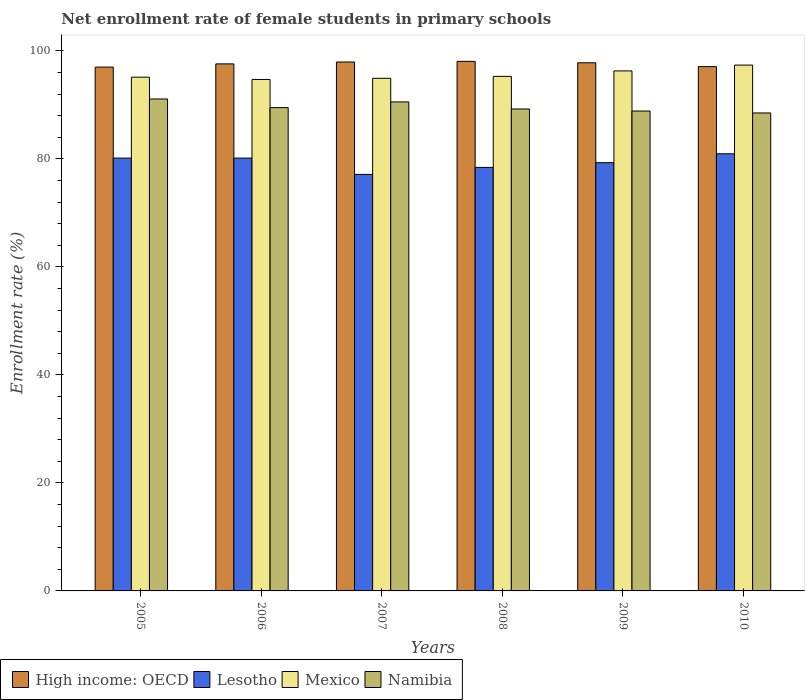How many different coloured bars are there?
Give a very brief answer. 4. How many groups of bars are there?
Your response must be concise. 6. Are the number of bars per tick equal to the number of legend labels?
Your response must be concise. Yes. Are the number of bars on each tick of the X-axis equal?
Provide a succinct answer. Yes. In how many cases, is the number of bars for a given year not equal to the number of legend labels?
Your answer should be compact. 0. What is the net enrollment rate of female students in primary schools in Lesotho in 2006?
Offer a terse response. 80.16. Across all years, what is the maximum net enrollment rate of female students in primary schools in Mexico?
Provide a succinct answer. 97.39. Across all years, what is the minimum net enrollment rate of female students in primary schools in Namibia?
Keep it short and to the point. 88.52. What is the total net enrollment rate of female students in primary schools in Namibia in the graph?
Provide a short and direct response. 537.83. What is the difference between the net enrollment rate of female students in primary schools in High income: OECD in 2006 and that in 2007?
Keep it short and to the point. -0.35. What is the difference between the net enrollment rate of female students in primary schools in Lesotho in 2008 and the net enrollment rate of female students in primary schools in Mexico in 2005?
Keep it short and to the point. -16.71. What is the average net enrollment rate of female students in primary schools in High income: OECD per year?
Provide a short and direct response. 97.59. In the year 2010, what is the difference between the net enrollment rate of female students in primary schools in Namibia and net enrollment rate of female students in primary schools in High income: OECD?
Make the answer very short. -8.58. What is the ratio of the net enrollment rate of female students in primary schools in Mexico in 2007 to that in 2009?
Provide a short and direct response. 0.99. What is the difference between the highest and the second highest net enrollment rate of female students in primary schools in Namibia?
Your answer should be compact. 0.54. What is the difference between the highest and the lowest net enrollment rate of female students in primary schools in Mexico?
Offer a terse response. 2.66. Is it the case that in every year, the sum of the net enrollment rate of female students in primary schools in High income: OECD and net enrollment rate of female students in primary schools in Namibia is greater than the sum of net enrollment rate of female students in primary schools in Lesotho and net enrollment rate of female students in primary schools in Mexico?
Keep it short and to the point. No. What does the 2nd bar from the left in 2007 represents?
Ensure brevity in your answer.  Lesotho. What does the 1st bar from the right in 2005 represents?
Keep it short and to the point. Namibia. Is it the case that in every year, the sum of the net enrollment rate of female students in primary schools in Mexico and net enrollment rate of female students in primary schools in Namibia is greater than the net enrollment rate of female students in primary schools in High income: OECD?
Keep it short and to the point. Yes. How many bars are there?
Provide a short and direct response. 24. Are all the bars in the graph horizontal?
Offer a very short reply. No. How many years are there in the graph?
Provide a succinct answer. 6. What is the difference between two consecutive major ticks on the Y-axis?
Keep it short and to the point. 20. Does the graph contain grids?
Ensure brevity in your answer.  No. Where does the legend appear in the graph?
Provide a short and direct response. Bottom left. What is the title of the graph?
Keep it short and to the point. Net enrollment rate of female students in primary schools. Does "Saudi Arabia" appear as one of the legend labels in the graph?
Give a very brief answer. No. What is the label or title of the Y-axis?
Give a very brief answer. Enrollment rate (%). What is the Enrollment rate (%) of High income: OECD in 2005?
Keep it short and to the point. 97.01. What is the Enrollment rate (%) in Lesotho in 2005?
Provide a short and direct response. 80.16. What is the Enrollment rate (%) in Mexico in 2005?
Ensure brevity in your answer.  95.14. What is the Enrollment rate (%) of Namibia in 2005?
Your response must be concise. 91.11. What is the Enrollment rate (%) in High income: OECD in 2006?
Keep it short and to the point. 97.61. What is the Enrollment rate (%) in Lesotho in 2006?
Make the answer very short. 80.16. What is the Enrollment rate (%) of Mexico in 2006?
Ensure brevity in your answer.  94.72. What is the Enrollment rate (%) in Namibia in 2006?
Keep it short and to the point. 89.51. What is the Enrollment rate (%) in High income: OECD in 2007?
Your answer should be compact. 97.96. What is the Enrollment rate (%) in Lesotho in 2007?
Offer a terse response. 77.14. What is the Enrollment rate (%) in Mexico in 2007?
Ensure brevity in your answer.  94.94. What is the Enrollment rate (%) of Namibia in 2007?
Offer a terse response. 90.56. What is the Enrollment rate (%) of High income: OECD in 2008?
Make the answer very short. 98.08. What is the Enrollment rate (%) in Lesotho in 2008?
Your response must be concise. 78.43. What is the Enrollment rate (%) of Mexico in 2008?
Provide a short and direct response. 95.3. What is the Enrollment rate (%) of Namibia in 2008?
Provide a succinct answer. 89.25. What is the Enrollment rate (%) of High income: OECD in 2009?
Your response must be concise. 97.81. What is the Enrollment rate (%) in Lesotho in 2009?
Make the answer very short. 79.31. What is the Enrollment rate (%) of Mexico in 2009?
Your answer should be compact. 96.31. What is the Enrollment rate (%) in Namibia in 2009?
Make the answer very short. 88.88. What is the Enrollment rate (%) of High income: OECD in 2010?
Your answer should be very brief. 97.1. What is the Enrollment rate (%) of Lesotho in 2010?
Offer a terse response. 80.96. What is the Enrollment rate (%) in Mexico in 2010?
Make the answer very short. 97.39. What is the Enrollment rate (%) in Namibia in 2010?
Provide a succinct answer. 88.52. Across all years, what is the maximum Enrollment rate (%) in High income: OECD?
Provide a short and direct response. 98.08. Across all years, what is the maximum Enrollment rate (%) of Lesotho?
Provide a succinct answer. 80.96. Across all years, what is the maximum Enrollment rate (%) in Mexico?
Keep it short and to the point. 97.39. Across all years, what is the maximum Enrollment rate (%) of Namibia?
Your answer should be compact. 91.11. Across all years, what is the minimum Enrollment rate (%) in High income: OECD?
Make the answer very short. 97.01. Across all years, what is the minimum Enrollment rate (%) in Lesotho?
Give a very brief answer. 77.14. Across all years, what is the minimum Enrollment rate (%) of Mexico?
Provide a succinct answer. 94.72. Across all years, what is the minimum Enrollment rate (%) in Namibia?
Ensure brevity in your answer.  88.52. What is the total Enrollment rate (%) in High income: OECD in the graph?
Provide a succinct answer. 585.57. What is the total Enrollment rate (%) in Lesotho in the graph?
Give a very brief answer. 476.16. What is the total Enrollment rate (%) of Mexico in the graph?
Your answer should be compact. 573.79. What is the total Enrollment rate (%) in Namibia in the graph?
Ensure brevity in your answer.  537.83. What is the difference between the Enrollment rate (%) of High income: OECD in 2005 and that in 2006?
Provide a succinct answer. -0.6. What is the difference between the Enrollment rate (%) in Lesotho in 2005 and that in 2006?
Your response must be concise. 0. What is the difference between the Enrollment rate (%) of Mexico in 2005 and that in 2006?
Offer a very short reply. 0.42. What is the difference between the Enrollment rate (%) in Namibia in 2005 and that in 2006?
Provide a short and direct response. 1.6. What is the difference between the Enrollment rate (%) in High income: OECD in 2005 and that in 2007?
Provide a short and direct response. -0.95. What is the difference between the Enrollment rate (%) in Lesotho in 2005 and that in 2007?
Ensure brevity in your answer.  3.02. What is the difference between the Enrollment rate (%) in Mexico in 2005 and that in 2007?
Provide a succinct answer. 0.21. What is the difference between the Enrollment rate (%) of Namibia in 2005 and that in 2007?
Your answer should be compact. 0.54. What is the difference between the Enrollment rate (%) of High income: OECD in 2005 and that in 2008?
Provide a short and direct response. -1.07. What is the difference between the Enrollment rate (%) in Lesotho in 2005 and that in 2008?
Provide a succinct answer. 1.73. What is the difference between the Enrollment rate (%) in Mexico in 2005 and that in 2008?
Provide a succinct answer. -0.15. What is the difference between the Enrollment rate (%) in Namibia in 2005 and that in 2008?
Give a very brief answer. 1.86. What is the difference between the Enrollment rate (%) of High income: OECD in 2005 and that in 2009?
Keep it short and to the point. -0.8. What is the difference between the Enrollment rate (%) in Lesotho in 2005 and that in 2009?
Your answer should be compact. 0.85. What is the difference between the Enrollment rate (%) of Mexico in 2005 and that in 2009?
Ensure brevity in your answer.  -1.16. What is the difference between the Enrollment rate (%) of Namibia in 2005 and that in 2009?
Your answer should be compact. 2.23. What is the difference between the Enrollment rate (%) in High income: OECD in 2005 and that in 2010?
Offer a terse response. -0.09. What is the difference between the Enrollment rate (%) in Lesotho in 2005 and that in 2010?
Your answer should be compact. -0.8. What is the difference between the Enrollment rate (%) in Mexico in 2005 and that in 2010?
Ensure brevity in your answer.  -2.24. What is the difference between the Enrollment rate (%) of Namibia in 2005 and that in 2010?
Your response must be concise. 2.59. What is the difference between the Enrollment rate (%) in High income: OECD in 2006 and that in 2007?
Your answer should be very brief. -0.35. What is the difference between the Enrollment rate (%) of Lesotho in 2006 and that in 2007?
Give a very brief answer. 3.02. What is the difference between the Enrollment rate (%) of Mexico in 2006 and that in 2007?
Ensure brevity in your answer.  -0.21. What is the difference between the Enrollment rate (%) of Namibia in 2006 and that in 2007?
Provide a short and direct response. -1.06. What is the difference between the Enrollment rate (%) of High income: OECD in 2006 and that in 2008?
Keep it short and to the point. -0.47. What is the difference between the Enrollment rate (%) of Lesotho in 2006 and that in 2008?
Make the answer very short. 1.73. What is the difference between the Enrollment rate (%) of Mexico in 2006 and that in 2008?
Ensure brevity in your answer.  -0.57. What is the difference between the Enrollment rate (%) of Namibia in 2006 and that in 2008?
Make the answer very short. 0.25. What is the difference between the Enrollment rate (%) in High income: OECD in 2006 and that in 2009?
Your response must be concise. -0.2. What is the difference between the Enrollment rate (%) of Lesotho in 2006 and that in 2009?
Ensure brevity in your answer.  0.85. What is the difference between the Enrollment rate (%) in Mexico in 2006 and that in 2009?
Provide a succinct answer. -1.58. What is the difference between the Enrollment rate (%) of Namibia in 2006 and that in 2009?
Offer a terse response. 0.63. What is the difference between the Enrollment rate (%) in High income: OECD in 2006 and that in 2010?
Give a very brief answer. 0.5. What is the difference between the Enrollment rate (%) in Lesotho in 2006 and that in 2010?
Provide a succinct answer. -0.8. What is the difference between the Enrollment rate (%) of Mexico in 2006 and that in 2010?
Provide a succinct answer. -2.66. What is the difference between the Enrollment rate (%) in Namibia in 2006 and that in 2010?
Make the answer very short. 0.99. What is the difference between the Enrollment rate (%) of High income: OECD in 2007 and that in 2008?
Ensure brevity in your answer.  -0.12. What is the difference between the Enrollment rate (%) in Lesotho in 2007 and that in 2008?
Keep it short and to the point. -1.29. What is the difference between the Enrollment rate (%) in Mexico in 2007 and that in 2008?
Provide a succinct answer. -0.36. What is the difference between the Enrollment rate (%) in Namibia in 2007 and that in 2008?
Your answer should be very brief. 1.31. What is the difference between the Enrollment rate (%) of High income: OECD in 2007 and that in 2009?
Your answer should be compact. 0.15. What is the difference between the Enrollment rate (%) of Lesotho in 2007 and that in 2009?
Offer a terse response. -2.17. What is the difference between the Enrollment rate (%) in Mexico in 2007 and that in 2009?
Offer a very short reply. -1.37. What is the difference between the Enrollment rate (%) in Namibia in 2007 and that in 2009?
Your answer should be very brief. 1.69. What is the difference between the Enrollment rate (%) in High income: OECD in 2007 and that in 2010?
Ensure brevity in your answer.  0.86. What is the difference between the Enrollment rate (%) in Lesotho in 2007 and that in 2010?
Make the answer very short. -3.82. What is the difference between the Enrollment rate (%) of Mexico in 2007 and that in 2010?
Give a very brief answer. -2.45. What is the difference between the Enrollment rate (%) of Namibia in 2007 and that in 2010?
Ensure brevity in your answer.  2.05. What is the difference between the Enrollment rate (%) in High income: OECD in 2008 and that in 2009?
Your answer should be compact. 0.27. What is the difference between the Enrollment rate (%) of Lesotho in 2008 and that in 2009?
Keep it short and to the point. -0.88. What is the difference between the Enrollment rate (%) in Mexico in 2008 and that in 2009?
Your answer should be very brief. -1.01. What is the difference between the Enrollment rate (%) in Namibia in 2008 and that in 2009?
Offer a very short reply. 0.37. What is the difference between the Enrollment rate (%) in High income: OECD in 2008 and that in 2010?
Make the answer very short. 0.97. What is the difference between the Enrollment rate (%) in Lesotho in 2008 and that in 2010?
Provide a succinct answer. -2.53. What is the difference between the Enrollment rate (%) in Mexico in 2008 and that in 2010?
Provide a short and direct response. -2.09. What is the difference between the Enrollment rate (%) in Namibia in 2008 and that in 2010?
Give a very brief answer. 0.73. What is the difference between the Enrollment rate (%) of High income: OECD in 2009 and that in 2010?
Provide a short and direct response. 0.71. What is the difference between the Enrollment rate (%) in Lesotho in 2009 and that in 2010?
Offer a very short reply. -1.65. What is the difference between the Enrollment rate (%) in Mexico in 2009 and that in 2010?
Keep it short and to the point. -1.08. What is the difference between the Enrollment rate (%) of Namibia in 2009 and that in 2010?
Make the answer very short. 0.36. What is the difference between the Enrollment rate (%) of High income: OECD in 2005 and the Enrollment rate (%) of Lesotho in 2006?
Provide a short and direct response. 16.85. What is the difference between the Enrollment rate (%) of High income: OECD in 2005 and the Enrollment rate (%) of Mexico in 2006?
Give a very brief answer. 2.29. What is the difference between the Enrollment rate (%) in High income: OECD in 2005 and the Enrollment rate (%) in Namibia in 2006?
Give a very brief answer. 7.5. What is the difference between the Enrollment rate (%) in Lesotho in 2005 and the Enrollment rate (%) in Mexico in 2006?
Your answer should be compact. -14.56. What is the difference between the Enrollment rate (%) in Lesotho in 2005 and the Enrollment rate (%) in Namibia in 2006?
Offer a very short reply. -9.35. What is the difference between the Enrollment rate (%) in Mexico in 2005 and the Enrollment rate (%) in Namibia in 2006?
Keep it short and to the point. 5.64. What is the difference between the Enrollment rate (%) of High income: OECD in 2005 and the Enrollment rate (%) of Lesotho in 2007?
Ensure brevity in your answer.  19.87. What is the difference between the Enrollment rate (%) in High income: OECD in 2005 and the Enrollment rate (%) in Mexico in 2007?
Keep it short and to the point. 2.07. What is the difference between the Enrollment rate (%) of High income: OECD in 2005 and the Enrollment rate (%) of Namibia in 2007?
Provide a short and direct response. 6.45. What is the difference between the Enrollment rate (%) in Lesotho in 2005 and the Enrollment rate (%) in Mexico in 2007?
Make the answer very short. -14.78. What is the difference between the Enrollment rate (%) of Lesotho in 2005 and the Enrollment rate (%) of Namibia in 2007?
Your response must be concise. -10.4. What is the difference between the Enrollment rate (%) of Mexico in 2005 and the Enrollment rate (%) of Namibia in 2007?
Provide a succinct answer. 4.58. What is the difference between the Enrollment rate (%) in High income: OECD in 2005 and the Enrollment rate (%) in Lesotho in 2008?
Your answer should be compact. 18.58. What is the difference between the Enrollment rate (%) of High income: OECD in 2005 and the Enrollment rate (%) of Mexico in 2008?
Make the answer very short. 1.72. What is the difference between the Enrollment rate (%) of High income: OECD in 2005 and the Enrollment rate (%) of Namibia in 2008?
Your answer should be compact. 7.76. What is the difference between the Enrollment rate (%) of Lesotho in 2005 and the Enrollment rate (%) of Mexico in 2008?
Your response must be concise. -15.13. What is the difference between the Enrollment rate (%) in Lesotho in 2005 and the Enrollment rate (%) in Namibia in 2008?
Offer a terse response. -9.09. What is the difference between the Enrollment rate (%) in Mexico in 2005 and the Enrollment rate (%) in Namibia in 2008?
Your answer should be very brief. 5.89. What is the difference between the Enrollment rate (%) in High income: OECD in 2005 and the Enrollment rate (%) in Lesotho in 2009?
Give a very brief answer. 17.7. What is the difference between the Enrollment rate (%) of High income: OECD in 2005 and the Enrollment rate (%) of Mexico in 2009?
Provide a short and direct response. 0.7. What is the difference between the Enrollment rate (%) of High income: OECD in 2005 and the Enrollment rate (%) of Namibia in 2009?
Offer a very short reply. 8.13. What is the difference between the Enrollment rate (%) in Lesotho in 2005 and the Enrollment rate (%) in Mexico in 2009?
Offer a very short reply. -16.15. What is the difference between the Enrollment rate (%) in Lesotho in 2005 and the Enrollment rate (%) in Namibia in 2009?
Your answer should be very brief. -8.72. What is the difference between the Enrollment rate (%) of Mexico in 2005 and the Enrollment rate (%) of Namibia in 2009?
Your answer should be compact. 6.27. What is the difference between the Enrollment rate (%) of High income: OECD in 2005 and the Enrollment rate (%) of Lesotho in 2010?
Your answer should be compact. 16.05. What is the difference between the Enrollment rate (%) of High income: OECD in 2005 and the Enrollment rate (%) of Mexico in 2010?
Your answer should be very brief. -0.37. What is the difference between the Enrollment rate (%) in High income: OECD in 2005 and the Enrollment rate (%) in Namibia in 2010?
Make the answer very short. 8.49. What is the difference between the Enrollment rate (%) in Lesotho in 2005 and the Enrollment rate (%) in Mexico in 2010?
Keep it short and to the point. -17.22. What is the difference between the Enrollment rate (%) in Lesotho in 2005 and the Enrollment rate (%) in Namibia in 2010?
Your response must be concise. -8.36. What is the difference between the Enrollment rate (%) of Mexico in 2005 and the Enrollment rate (%) of Namibia in 2010?
Provide a succinct answer. 6.63. What is the difference between the Enrollment rate (%) of High income: OECD in 2006 and the Enrollment rate (%) of Lesotho in 2007?
Your response must be concise. 20.47. What is the difference between the Enrollment rate (%) of High income: OECD in 2006 and the Enrollment rate (%) of Mexico in 2007?
Your answer should be compact. 2.67. What is the difference between the Enrollment rate (%) of High income: OECD in 2006 and the Enrollment rate (%) of Namibia in 2007?
Make the answer very short. 7.04. What is the difference between the Enrollment rate (%) of Lesotho in 2006 and the Enrollment rate (%) of Mexico in 2007?
Provide a succinct answer. -14.78. What is the difference between the Enrollment rate (%) of Lesotho in 2006 and the Enrollment rate (%) of Namibia in 2007?
Provide a short and direct response. -10.41. What is the difference between the Enrollment rate (%) of Mexico in 2006 and the Enrollment rate (%) of Namibia in 2007?
Give a very brief answer. 4.16. What is the difference between the Enrollment rate (%) of High income: OECD in 2006 and the Enrollment rate (%) of Lesotho in 2008?
Keep it short and to the point. 19.18. What is the difference between the Enrollment rate (%) of High income: OECD in 2006 and the Enrollment rate (%) of Mexico in 2008?
Give a very brief answer. 2.31. What is the difference between the Enrollment rate (%) in High income: OECD in 2006 and the Enrollment rate (%) in Namibia in 2008?
Offer a very short reply. 8.35. What is the difference between the Enrollment rate (%) of Lesotho in 2006 and the Enrollment rate (%) of Mexico in 2008?
Keep it short and to the point. -15.14. What is the difference between the Enrollment rate (%) of Lesotho in 2006 and the Enrollment rate (%) of Namibia in 2008?
Ensure brevity in your answer.  -9.1. What is the difference between the Enrollment rate (%) in Mexico in 2006 and the Enrollment rate (%) in Namibia in 2008?
Give a very brief answer. 5.47. What is the difference between the Enrollment rate (%) in High income: OECD in 2006 and the Enrollment rate (%) in Lesotho in 2009?
Ensure brevity in your answer.  18.29. What is the difference between the Enrollment rate (%) of High income: OECD in 2006 and the Enrollment rate (%) of Mexico in 2009?
Offer a terse response. 1.3. What is the difference between the Enrollment rate (%) in High income: OECD in 2006 and the Enrollment rate (%) in Namibia in 2009?
Your answer should be very brief. 8.73. What is the difference between the Enrollment rate (%) in Lesotho in 2006 and the Enrollment rate (%) in Mexico in 2009?
Make the answer very short. -16.15. What is the difference between the Enrollment rate (%) of Lesotho in 2006 and the Enrollment rate (%) of Namibia in 2009?
Keep it short and to the point. -8.72. What is the difference between the Enrollment rate (%) of Mexico in 2006 and the Enrollment rate (%) of Namibia in 2009?
Your response must be concise. 5.84. What is the difference between the Enrollment rate (%) of High income: OECD in 2006 and the Enrollment rate (%) of Lesotho in 2010?
Keep it short and to the point. 16.65. What is the difference between the Enrollment rate (%) of High income: OECD in 2006 and the Enrollment rate (%) of Mexico in 2010?
Give a very brief answer. 0.22. What is the difference between the Enrollment rate (%) of High income: OECD in 2006 and the Enrollment rate (%) of Namibia in 2010?
Keep it short and to the point. 9.09. What is the difference between the Enrollment rate (%) in Lesotho in 2006 and the Enrollment rate (%) in Mexico in 2010?
Provide a succinct answer. -17.23. What is the difference between the Enrollment rate (%) of Lesotho in 2006 and the Enrollment rate (%) of Namibia in 2010?
Give a very brief answer. -8.36. What is the difference between the Enrollment rate (%) in Mexico in 2006 and the Enrollment rate (%) in Namibia in 2010?
Offer a very short reply. 6.21. What is the difference between the Enrollment rate (%) in High income: OECD in 2007 and the Enrollment rate (%) in Lesotho in 2008?
Your response must be concise. 19.53. What is the difference between the Enrollment rate (%) in High income: OECD in 2007 and the Enrollment rate (%) in Mexico in 2008?
Offer a very short reply. 2.66. What is the difference between the Enrollment rate (%) in High income: OECD in 2007 and the Enrollment rate (%) in Namibia in 2008?
Provide a short and direct response. 8.71. What is the difference between the Enrollment rate (%) of Lesotho in 2007 and the Enrollment rate (%) of Mexico in 2008?
Offer a terse response. -18.16. What is the difference between the Enrollment rate (%) in Lesotho in 2007 and the Enrollment rate (%) in Namibia in 2008?
Give a very brief answer. -12.11. What is the difference between the Enrollment rate (%) of Mexico in 2007 and the Enrollment rate (%) of Namibia in 2008?
Provide a short and direct response. 5.69. What is the difference between the Enrollment rate (%) of High income: OECD in 2007 and the Enrollment rate (%) of Lesotho in 2009?
Make the answer very short. 18.65. What is the difference between the Enrollment rate (%) in High income: OECD in 2007 and the Enrollment rate (%) in Mexico in 2009?
Provide a short and direct response. 1.65. What is the difference between the Enrollment rate (%) in High income: OECD in 2007 and the Enrollment rate (%) in Namibia in 2009?
Your answer should be compact. 9.08. What is the difference between the Enrollment rate (%) of Lesotho in 2007 and the Enrollment rate (%) of Mexico in 2009?
Your answer should be compact. -19.17. What is the difference between the Enrollment rate (%) of Lesotho in 2007 and the Enrollment rate (%) of Namibia in 2009?
Offer a terse response. -11.74. What is the difference between the Enrollment rate (%) in Mexico in 2007 and the Enrollment rate (%) in Namibia in 2009?
Provide a succinct answer. 6.06. What is the difference between the Enrollment rate (%) of High income: OECD in 2007 and the Enrollment rate (%) of Lesotho in 2010?
Offer a very short reply. 17. What is the difference between the Enrollment rate (%) of High income: OECD in 2007 and the Enrollment rate (%) of Mexico in 2010?
Offer a terse response. 0.57. What is the difference between the Enrollment rate (%) in High income: OECD in 2007 and the Enrollment rate (%) in Namibia in 2010?
Your response must be concise. 9.44. What is the difference between the Enrollment rate (%) of Lesotho in 2007 and the Enrollment rate (%) of Mexico in 2010?
Your answer should be compact. -20.25. What is the difference between the Enrollment rate (%) of Lesotho in 2007 and the Enrollment rate (%) of Namibia in 2010?
Offer a very short reply. -11.38. What is the difference between the Enrollment rate (%) in Mexico in 2007 and the Enrollment rate (%) in Namibia in 2010?
Your answer should be very brief. 6.42. What is the difference between the Enrollment rate (%) in High income: OECD in 2008 and the Enrollment rate (%) in Lesotho in 2009?
Offer a very short reply. 18.76. What is the difference between the Enrollment rate (%) in High income: OECD in 2008 and the Enrollment rate (%) in Mexico in 2009?
Your answer should be compact. 1.77. What is the difference between the Enrollment rate (%) in High income: OECD in 2008 and the Enrollment rate (%) in Namibia in 2009?
Your response must be concise. 9.2. What is the difference between the Enrollment rate (%) of Lesotho in 2008 and the Enrollment rate (%) of Mexico in 2009?
Make the answer very short. -17.87. What is the difference between the Enrollment rate (%) in Lesotho in 2008 and the Enrollment rate (%) in Namibia in 2009?
Your response must be concise. -10.45. What is the difference between the Enrollment rate (%) in Mexico in 2008 and the Enrollment rate (%) in Namibia in 2009?
Ensure brevity in your answer.  6.42. What is the difference between the Enrollment rate (%) in High income: OECD in 2008 and the Enrollment rate (%) in Lesotho in 2010?
Provide a short and direct response. 17.12. What is the difference between the Enrollment rate (%) of High income: OECD in 2008 and the Enrollment rate (%) of Mexico in 2010?
Provide a succinct answer. 0.69. What is the difference between the Enrollment rate (%) of High income: OECD in 2008 and the Enrollment rate (%) of Namibia in 2010?
Your response must be concise. 9.56. What is the difference between the Enrollment rate (%) in Lesotho in 2008 and the Enrollment rate (%) in Mexico in 2010?
Offer a terse response. -18.95. What is the difference between the Enrollment rate (%) in Lesotho in 2008 and the Enrollment rate (%) in Namibia in 2010?
Keep it short and to the point. -10.09. What is the difference between the Enrollment rate (%) in Mexico in 2008 and the Enrollment rate (%) in Namibia in 2010?
Offer a very short reply. 6.78. What is the difference between the Enrollment rate (%) in High income: OECD in 2009 and the Enrollment rate (%) in Lesotho in 2010?
Your response must be concise. 16.85. What is the difference between the Enrollment rate (%) of High income: OECD in 2009 and the Enrollment rate (%) of Mexico in 2010?
Offer a terse response. 0.42. What is the difference between the Enrollment rate (%) of High income: OECD in 2009 and the Enrollment rate (%) of Namibia in 2010?
Give a very brief answer. 9.29. What is the difference between the Enrollment rate (%) in Lesotho in 2009 and the Enrollment rate (%) in Mexico in 2010?
Offer a very short reply. -18.07. What is the difference between the Enrollment rate (%) of Lesotho in 2009 and the Enrollment rate (%) of Namibia in 2010?
Your answer should be compact. -9.21. What is the difference between the Enrollment rate (%) in Mexico in 2009 and the Enrollment rate (%) in Namibia in 2010?
Give a very brief answer. 7.79. What is the average Enrollment rate (%) in High income: OECD per year?
Offer a terse response. 97.59. What is the average Enrollment rate (%) in Lesotho per year?
Provide a short and direct response. 79.36. What is the average Enrollment rate (%) of Mexico per year?
Provide a short and direct response. 95.63. What is the average Enrollment rate (%) in Namibia per year?
Provide a short and direct response. 89.64. In the year 2005, what is the difference between the Enrollment rate (%) of High income: OECD and Enrollment rate (%) of Lesotho?
Your response must be concise. 16.85. In the year 2005, what is the difference between the Enrollment rate (%) in High income: OECD and Enrollment rate (%) in Mexico?
Your answer should be very brief. 1.87. In the year 2005, what is the difference between the Enrollment rate (%) in High income: OECD and Enrollment rate (%) in Namibia?
Make the answer very short. 5.9. In the year 2005, what is the difference between the Enrollment rate (%) of Lesotho and Enrollment rate (%) of Mexico?
Offer a very short reply. -14.98. In the year 2005, what is the difference between the Enrollment rate (%) in Lesotho and Enrollment rate (%) in Namibia?
Provide a succinct answer. -10.95. In the year 2005, what is the difference between the Enrollment rate (%) of Mexico and Enrollment rate (%) of Namibia?
Provide a succinct answer. 4.04. In the year 2006, what is the difference between the Enrollment rate (%) in High income: OECD and Enrollment rate (%) in Lesotho?
Provide a succinct answer. 17.45. In the year 2006, what is the difference between the Enrollment rate (%) in High income: OECD and Enrollment rate (%) in Mexico?
Offer a terse response. 2.88. In the year 2006, what is the difference between the Enrollment rate (%) of Lesotho and Enrollment rate (%) of Mexico?
Provide a short and direct response. -14.57. In the year 2006, what is the difference between the Enrollment rate (%) in Lesotho and Enrollment rate (%) in Namibia?
Your response must be concise. -9.35. In the year 2006, what is the difference between the Enrollment rate (%) of Mexico and Enrollment rate (%) of Namibia?
Your answer should be very brief. 5.22. In the year 2007, what is the difference between the Enrollment rate (%) in High income: OECD and Enrollment rate (%) in Lesotho?
Keep it short and to the point. 20.82. In the year 2007, what is the difference between the Enrollment rate (%) of High income: OECD and Enrollment rate (%) of Mexico?
Your answer should be compact. 3.02. In the year 2007, what is the difference between the Enrollment rate (%) of High income: OECD and Enrollment rate (%) of Namibia?
Your response must be concise. 7.4. In the year 2007, what is the difference between the Enrollment rate (%) in Lesotho and Enrollment rate (%) in Mexico?
Make the answer very short. -17.8. In the year 2007, what is the difference between the Enrollment rate (%) of Lesotho and Enrollment rate (%) of Namibia?
Your answer should be very brief. -13.43. In the year 2007, what is the difference between the Enrollment rate (%) of Mexico and Enrollment rate (%) of Namibia?
Give a very brief answer. 4.37. In the year 2008, what is the difference between the Enrollment rate (%) of High income: OECD and Enrollment rate (%) of Lesotho?
Keep it short and to the point. 19.64. In the year 2008, what is the difference between the Enrollment rate (%) of High income: OECD and Enrollment rate (%) of Mexico?
Make the answer very short. 2.78. In the year 2008, what is the difference between the Enrollment rate (%) of High income: OECD and Enrollment rate (%) of Namibia?
Your answer should be very brief. 8.82. In the year 2008, what is the difference between the Enrollment rate (%) of Lesotho and Enrollment rate (%) of Mexico?
Your response must be concise. -16.86. In the year 2008, what is the difference between the Enrollment rate (%) of Lesotho and Enrollment rate (%) of Namibia?
Keep it short and to the point. -10.82. In the year 2008, what is the difference between the Enrollment rate (%) in Mexico and Enrollment rate (%) in Namibia?
Offer a terse response. 6.04. In the year 2009, what is the difference between the Enrollment rate (%) in High income: OECD and Enrollment rate (%) in Lesotho?
Offer a very short reply. 18.5. In the year 2009, what is the difference between the Enrollment rate (%) of High income: OECD and Enrollment rate (%) of Mexico?
Offer a terse response. 1.5. In the year 2009, what is the difference between the Enrollment rate (%) of High income: OECD and Enrollment rate (%) of Namibia?
Give a very brief answer. 8.93. In the year 2009, what is the difference between the Enrollment rate (%) of Lesotho and Enrollment rate (%) of Mexico?
Provide a short and direct response. -16.99. In the year 2009, what is the difference between the Enrollment rate (%) of Lesotho and Enrollment rate (%) of Namibia?
Keep it short and to the point. -9.57. In the year 2009, what is the difference between the Enrollment rate (%) in Mexico and Enrollment rate (%) in Namibia?
Provide a succinct answer. 7.43. In the year 2010, what is the difference between the Enrollment rate (%) of High income: OECD and Enrollment rate (%) of Lesotho?
Your answer should be compact. 16.14. In the year 2010, what is the difference between the Enrollment rate (%) of High income: OECD and Enrollment rate (%) of Mexico?
Provide a short and direct response. -0.28. In the year 2010, what is the difference between the Enrollment rate (%) of High income: OECD and Enrollment rate (%) of Namibia?
Make the answer very short. 8.58. In the year 2010, what is the difference between the Enrollment rate (%) in Lesotho and Enrollment rate (%) in Mexico?
Offer a terse response. -16.43. In the year 2010, what is the difference between the Enrollment rate (%) of Lesotho and Enrollment rate (%) of Namibia?
Provide a short and direct response. -7.56. In the year 2010, what is the difference between the Enrollment rate (%) of Mexico and Enrollment rate (%) of Namibia?
Give a very brief answer. 8.87. What is the ratio of the Enrollment rate (%) in High income: OECD in 2005 to that in 2006?
Your response must be concise. 0.99. What is the ratio of the Enrollment rate (%) in Namibia in 2005 to that in 2006?
Your answer should be very brief. 1.02. What is the ratio of the Enrollment rate (%) in High income: OECD in 2005 to that in 2007?
Give a very brief answer. 0.99. What is the ratio of the Enrollment rate (%) in Lesotho in 2005 to that in 2007?
Provide a succinct answer. 1.04. What is the ratio of the Enrollment rate (%) of Mexico in 2005 to that in 2007?
Provide a short and direct response. 1. What is the ratio of the Enrollment rate (%) of High income: OECD in 2005 to that in 2008?
Provide a succinct answer. 0.99. What is the ratio of the Enrollment rate (%) in Lesotho in 2005 to that in 2008?
Make the answer very short. 1.02. What is the ratio of the Enrollment rate (%) in Namibia in 2005 to that in 2008?
Keep it short and to the point. 1.02. What is the ratio of the Enrollment rate (%) of High income: OECD in 2005 to that in 2009?
Your answer should be very brief. 0.99. What is the ratio of the Enrollment rate (%) in Lesotho in 2005 to that in 2009?
Offer a terse response. 1.01. What is the ratio of the Enrollment rate (%) of Mexico in 2005 to that in 2009?
Your answer should be compact. 0.99. What is the ratio of the Enrollment rate (%) of Namibia in 2005 to that in 2009?
Keep it short and to the point. 1.03. What is the ratio of the Enrollment rate (%) in Mexico in 2005 to that in 2010?
Offer a terse response. 0.98. What is the ratio of the Enrollment rate (%) in Namibia in 2005 to that in 2010?
Provide a short and direct response. 1.03. What is the ratio of the Enrollment rate (%) of High income: OECD in 2006 to that in 2007?
Give a very brief answer. 1. What is the ratio of the Enrollment rate (%) of Lesotho in 2006 to that in 2007?
Offer a very short reply. 1.04. What is the ratio of the Enrollment rate (%) in Namibia in 2006 to that in 2007?
Ensure brevity in your answer.  0.99. What is the ratio of the Enrollment rate (%) of Mexico in 2006 to that in 2008?
Make the answer very short. 0.99. What is the ratio of the Enrollment rate (%) in Namibia in 2006 to that in 2008?
Give a very brief answer. 1. What is the ratio of the Enrollment rate (%) of Lesotho in 2006 to that in 2009?
Offer a terse response. 1.01. What is the ratio of the Enrollment rate (%) of Mexico in 2006 to that in 2009?
Keep it short and to the point. 0.98. What is the ratio of the Enrollment rate (%) in Namibia in 2006 to that in 2009?
Keep it short and to the point. 1.01. What is the ratio of the Enrollment rate (%) of Lesotho in 2006 to that in 2010?
Give a very brief answer. 0.99. What is the ratio of the Enrollment rate (%) of Mexico in 2006 to that in 2010?
Your response must be concise. 0.97. What is the ratio of the Enrollment rate (%) of Namibia in 2006 to that in 2010?
Provide a short and direct response. 1.01. What is the ratio of the Enrollment rate (%) in High income: OECD in 2007 to that in 2008?
Offer a terse response. 1. What is the ratio of the Enrollment rate (%) of Lesotho in 2007 to that in 2008?
Provide a succinct answer. 0.98. What is the ratio of the Enrollment rate (%) of Namibia in 2007 to that in 2008?
Your answer should be compact. 1.01. What is the ratio of the Enrollment rate (%) of High income: OECD in 2007 to that in 2009?
Make the answer very short. 1. What is the ratio of the Enrollment rate (%) in Lesotho in 2007 to that in 2009?
Provide a short and direct response. 0.97. What is the ratio of the Enrollment rate (%) in Mexico in 2007 to that in 2009?
Keep it short and to the point. 0.99. What is the ratio of the Enrollment rate (%) of Namibia in 2007 to that in 2009?
Give a very brief answer. 1.02. What is the ratio of the Enrollment rate (%) of High income: OECD in 2007 to that in 2010?
Offer a very short reply. 1.01. What is the ratio of the Enrollment rate (%) in Lesotho in 2007 to that in 2010?
Provide a short and direct response. 0.95. What is the ratio of the Enrollment rate (%) of Mexico in 2007 to that in 2010?
Give a very brief answer. 0.97. What is the ratio of the Enrollment rate (%) in Namibia in 2007 to that in 2010?
Make the answer very short. 1.02. What is the ratio of the Enrollment rate (%) in High income: OECD in 2008 to that in 2009?
Offer a very short reply. 1. What is the ratio of the Enrollment rate (%) in Lesotho in 2008 to that in 2009?
Your answer should be very brief. 0.99. What is the ratio of the Enrollment rate (%) in Mexico in 2008 to that in 2009?
Your answer should be compact. 0.99. What is the ratio of the Enrollment rate (%) in Namibia in 2008 to that in 2009?
Ensure brevity in your answer.  1. What is the ratio of the Enrollment rate (%) of High income: OECD in 2008 to that in 2010?
Keep it short and to the point. 1.01. What is the ratio of the Enrollment rate (%) in Lesotho in 2008 to that in 2010?
Your response must be concise. 0.97. What is the ratio of the Enrollment rate (%) in Mexico in 2008 to that in 2010?
Make the answer very short. 0.98. What is the ratio of the Enrollment rate (%) of Namibia in 2008 to that in 2010?
Offer a very short reply. 1.01. What is the ratio of the Enrollment rate (%) of High income: OECD in 2009 to that in 2010?
Ensure brevity in your answer.  1.01. What is the ratio of the Enrollment rate (%) of Lesotho in 2009 to that in 2010?
Your answer should be very brief. 0.98. What is the ratio of the Enrollment rate (%) of Mexico in 2009 to that in 2010?
Give a very brief answer. 0.99. What is the ratio of the Enrollment rate (%) in Namibia in 2009 to that in 2010?
Your response must be concise. 1. What is the difference between the highest and the second highest Enrollment rate (%) of High income: OECD?
Provide a short and direct response. 0.12. What is the difference between the highest and the second highest Enrollment rate (%) of Lesotho?
Provide a short and direct response. 0.8. What is the difference between the highest and the second highest Enrollment rate (%) in Mexico?
Offer a terse response. 1.08. What is the difference between the highest and the second highest Enrollment rate (%) of Namibia?
Your response must be concise. 0.54. What is the difference between the highest and the lowest Enrollment rate (%) in High income: OECD?
Ensure brevity in your answer.  1.07. What is the difference between the highest and the lowest Enrollment rate (%) in Lesotho?
Ensure brevity in your answer.  3.82. What is the difference between the highest and the lowest Enrollment rate (%) of Mexico?
Offer a very short reply. 2.66. What is the difference between the highest and the lowest Enrollment rate (%) in Namibia?
Keep it short and to the point. 2.59. 